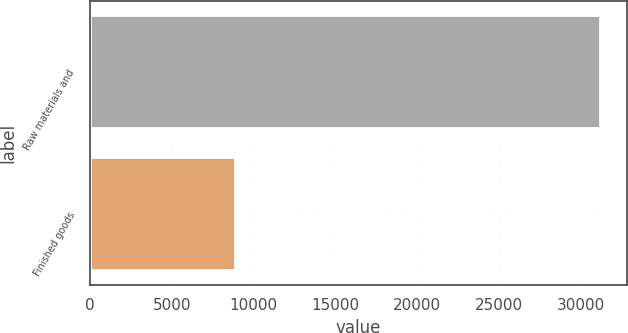Convert chart. <chart><loc_0><loc_0><loc_500><loc_500><bar_chart><fcel>Raw materials and<fcel>Finished goods<nl><fcel>31252<fcel>8922<nl></chart> 